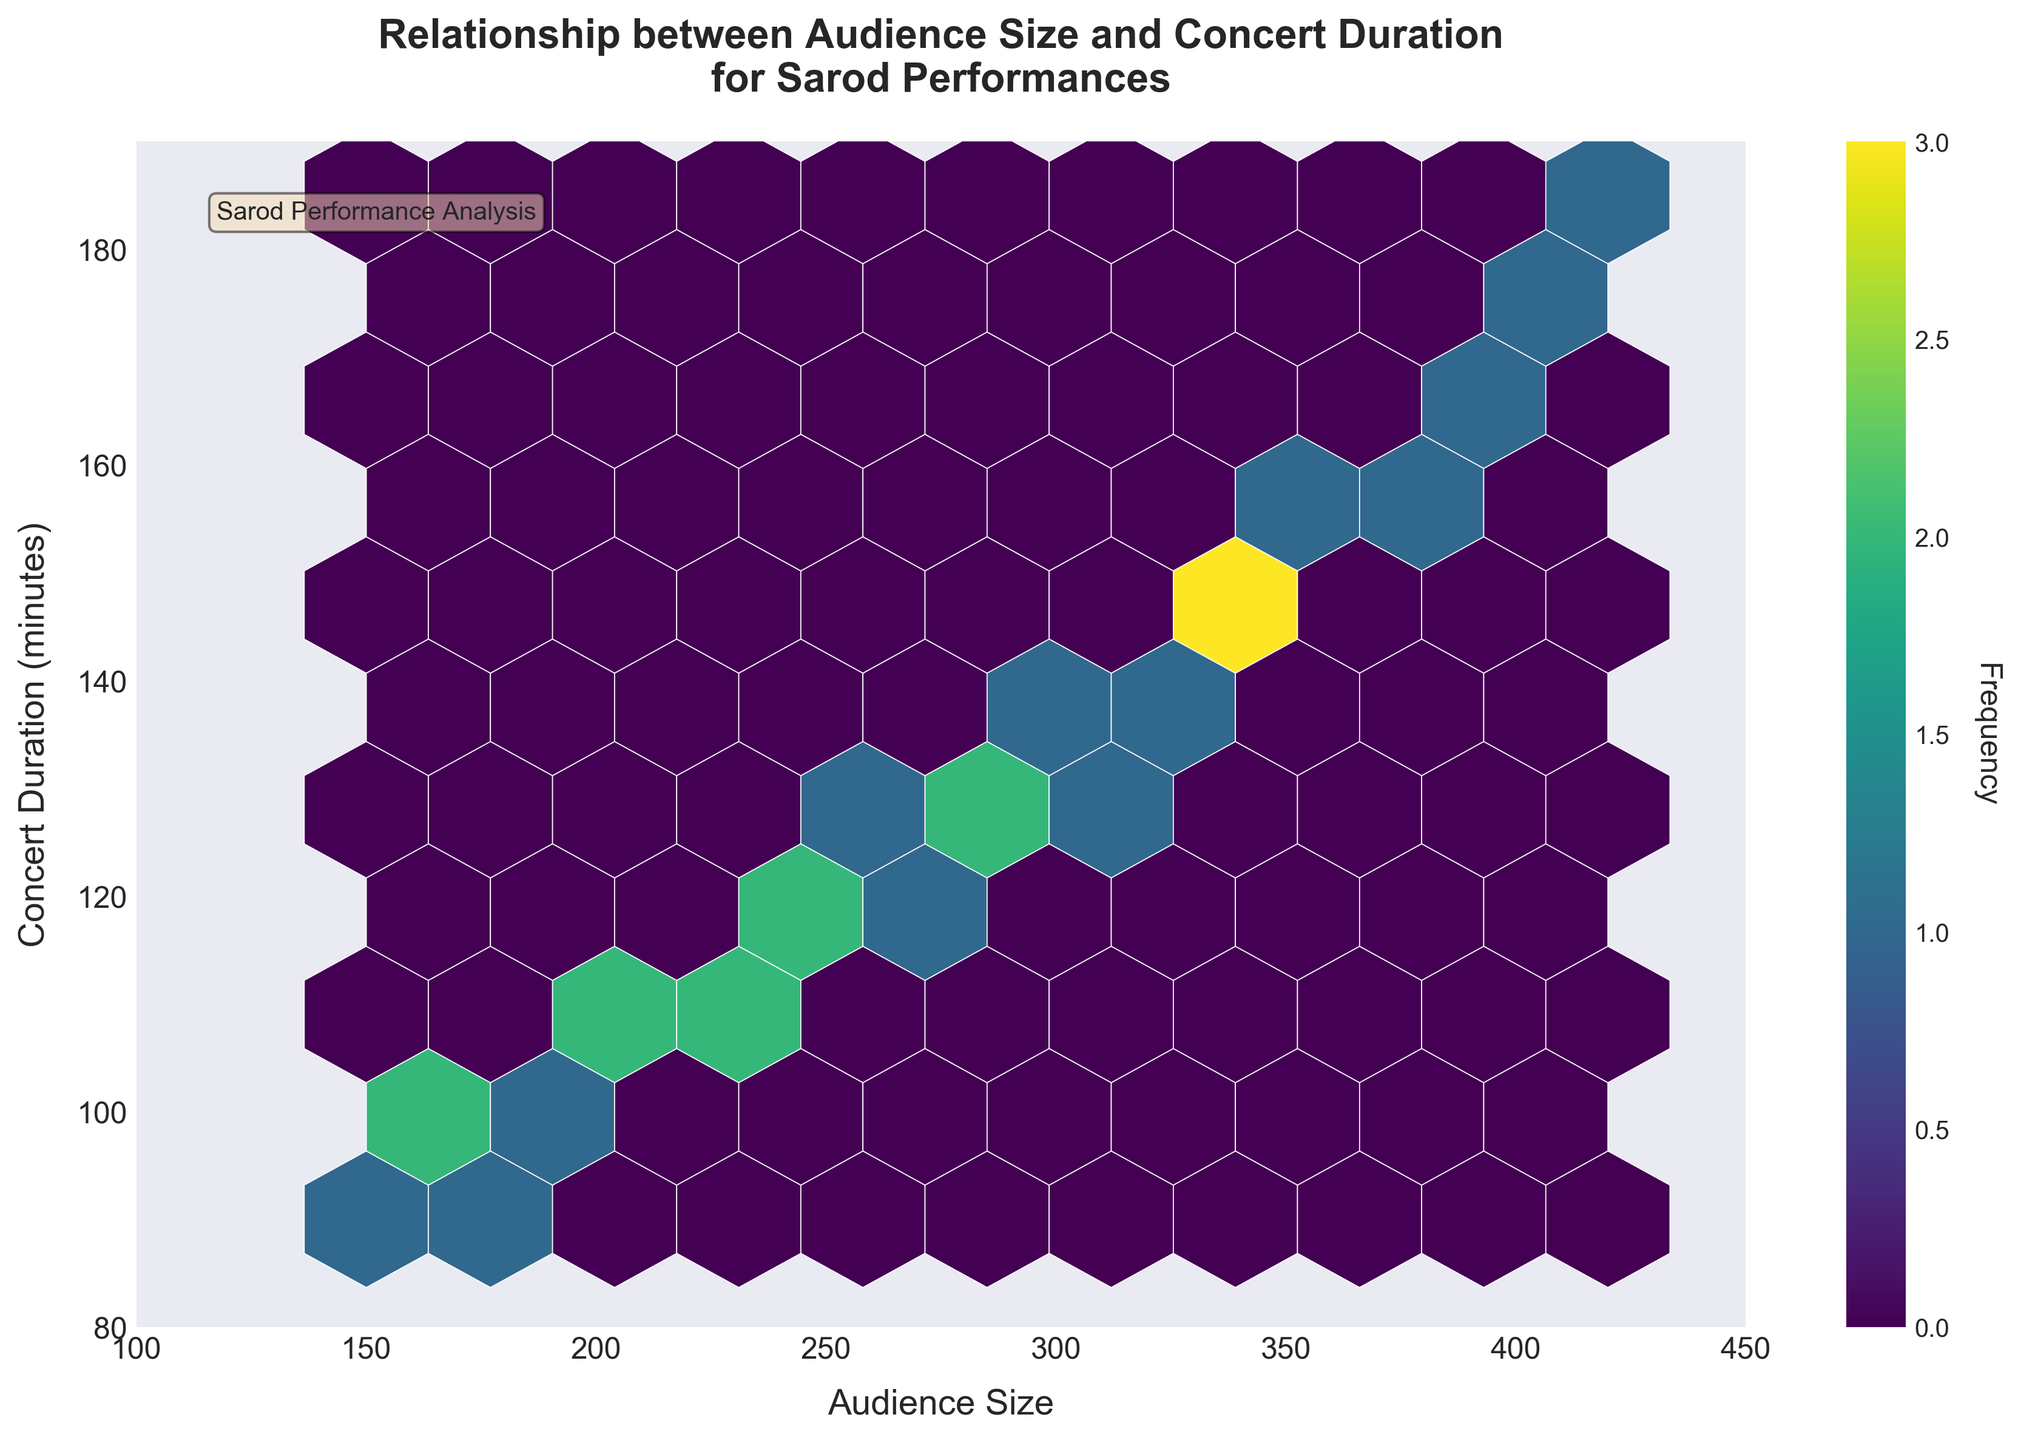What is the title of the figure? The title of the figure is displayed at the top of the plot. By looking at the plot, we can see the exact phrases used in the title.
Answer: Relationship between Audience Size and Concert Duration for Sarod Performances What is the color scheme used for the hexagons? The color of the hexagons ranges from dark to bright colors. By observing the legend and the hexagons, we can deduce that the 'viridis' color map is used.
Answer: Viridis What does the color bar on the right side represent? The color bar indicates the frequency of the data points within each hexagon, with different colors representing varying densities. This is a key component to understanding the distribution.
Answer: Frequency What is the range of Audience Size displayed on the x-axis? The x-axis shows the range of Audience Size from the leftmost to the rightmost limit. Observing these limits helps us determine the full range covered by the plot.
Answer: 100 to 450 How many hexagons are included in the gridsize? The plot's visual grid structure allows us to count or estimate the number of hexagons drawn along each dimension, typically guided by the plot's parameters if it’s not possible to directly count.
Answer: 10 Which area shows the highest frequency of data points? The color intensity indicates frequency, with the brightest most saturated regions representing higher data densities. By identifying such regions, we can pinpoint where the data points are most concentrated.
Answer: Around Audience Size of 220-280 and Concert Duration of 110-130 Is there a noticeable trend between audience size and concert duration? By visualizing the distribution of hexagons from the bottom-left to the top-right of the plot, a trend can be seen. This involves assessing whether data points generally increase together.
Answer: Yes What is the relationship between concert duration and audience size for concerts lasting about 120 minutes? Observing the data points around the 120-minute mark on the y-axis, we can see which audience sizes are common. This relationship is reflected in the density and positioning of hexagons at that y-value.
Answer: Audience size ranges from 250 to 260 What is the range of concert durations displayed on the y-axis? The y-axis shows the range of Concert Duration from the bottom to the top limit. Observing these limits helps us determine the full range covered by the plot.
Answer: 80 to 190 Between concerts with an audience size of 150 and 200, what is the range of typical concert durations? Focusing on the area between 150 and 200 on the x-axis, we then look up and down to see the bounds of the filled hexagons in those vertical segments, giving us the common duration range in this audience size bracket.
Answer: 90 to 105 minutes 